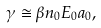Convert formula to latex. <formula><loc_0><loc_0><loc_500><loc_500>\gamma \cong \beta n _ { 0 } E _ { 0 } a _ { 0 } ,</formula> 